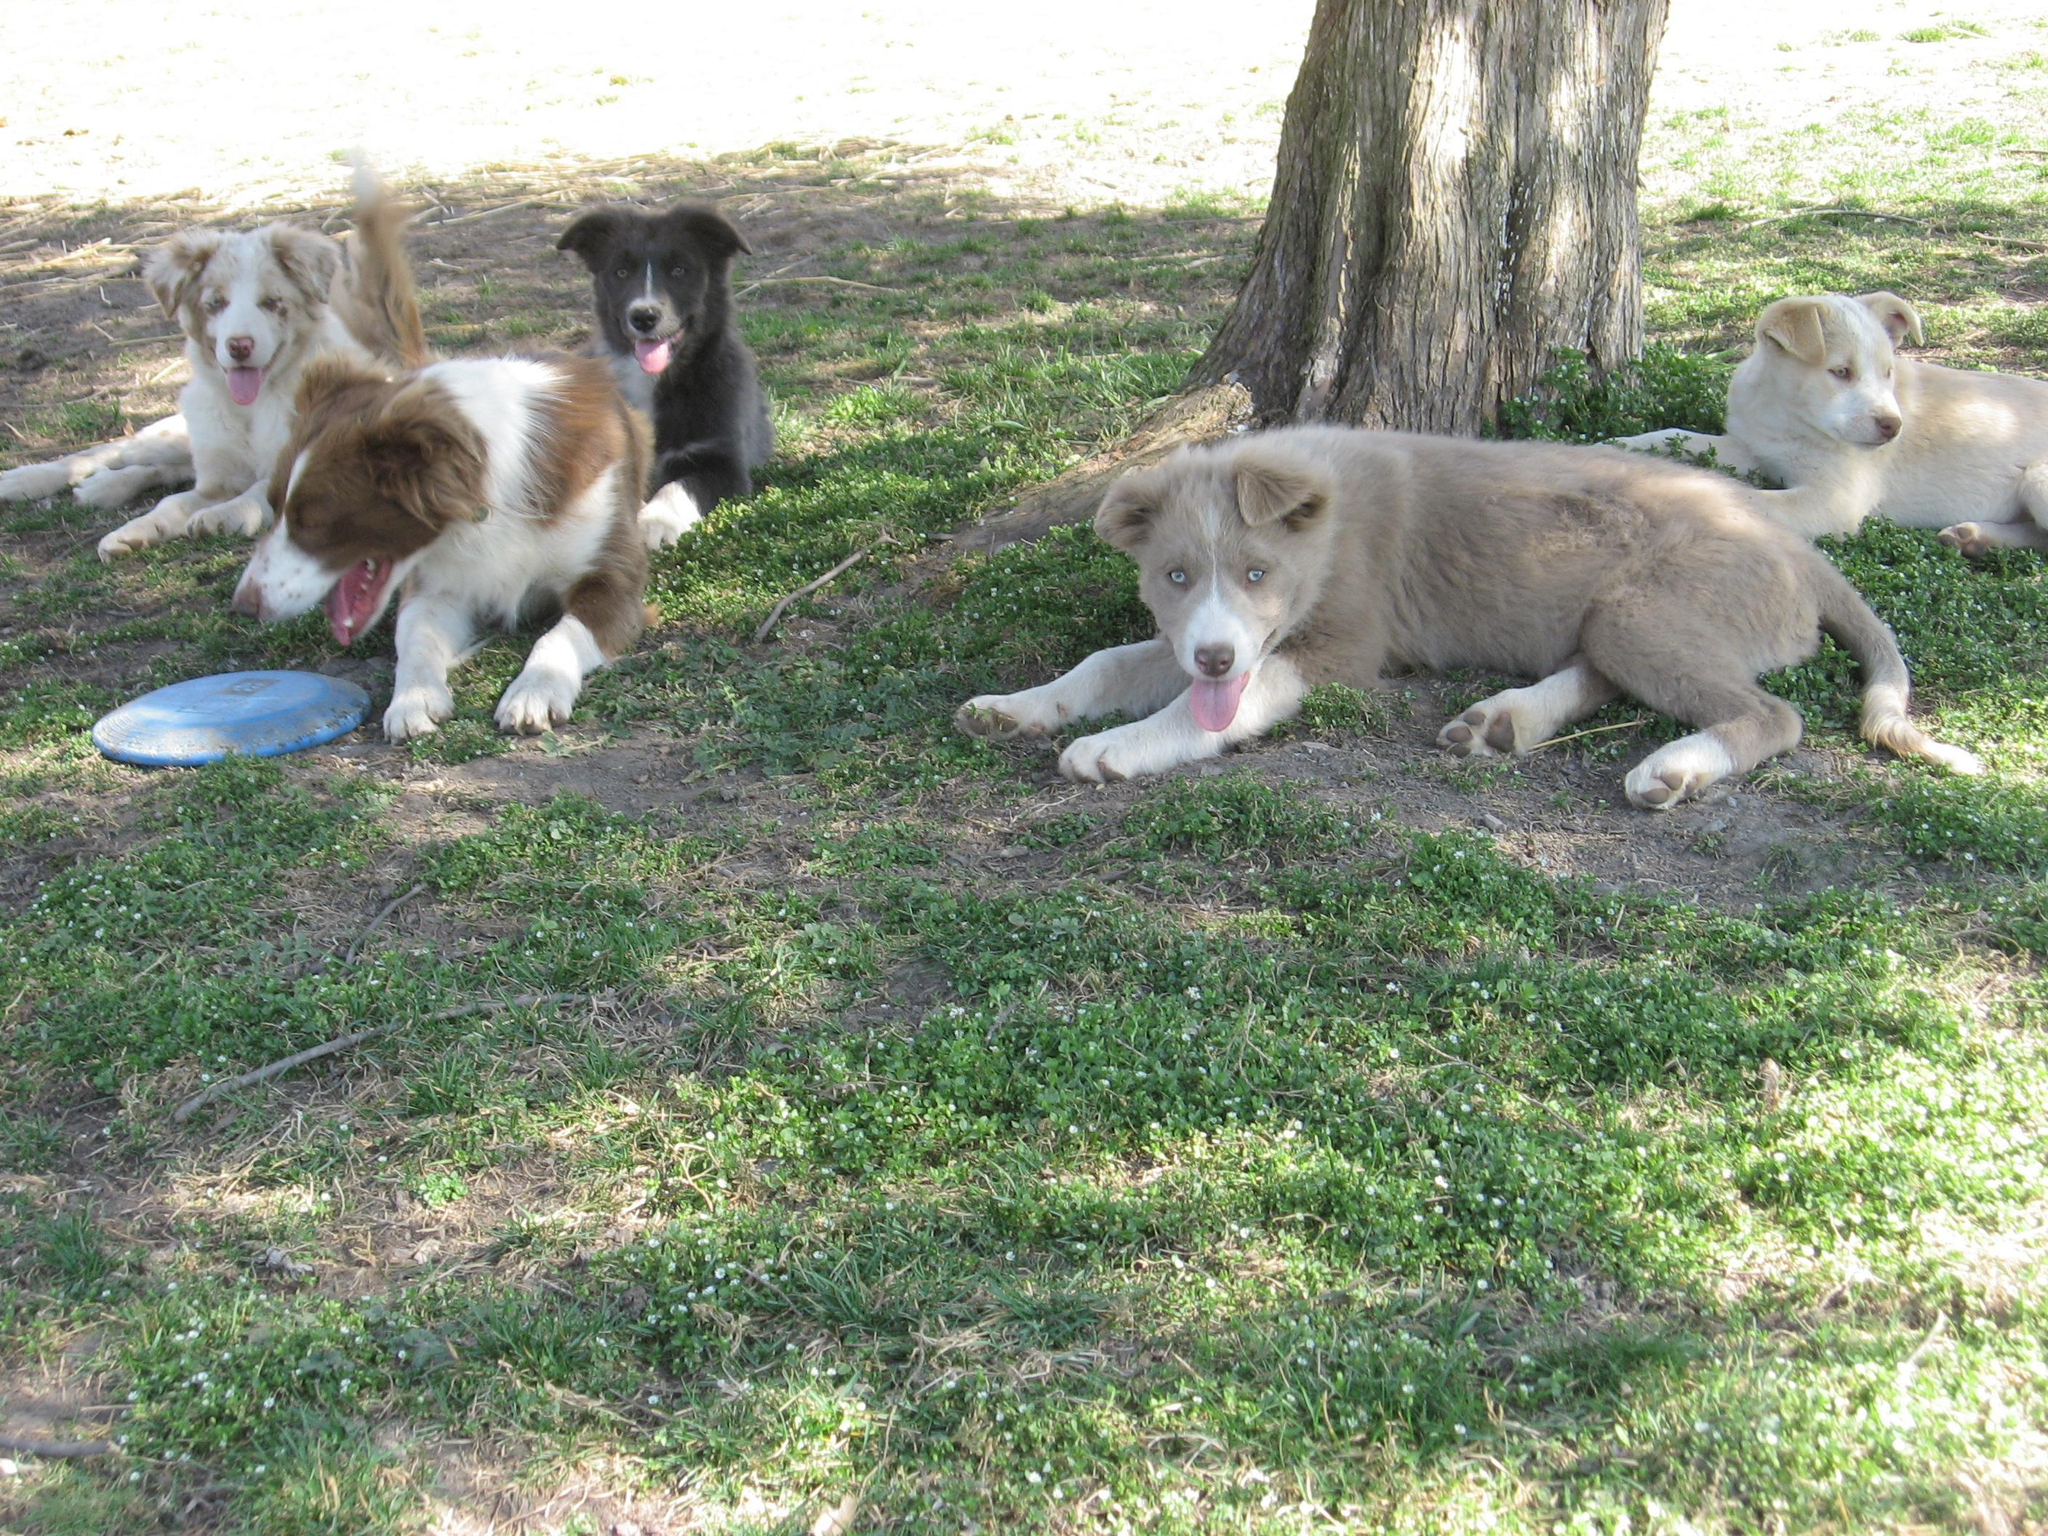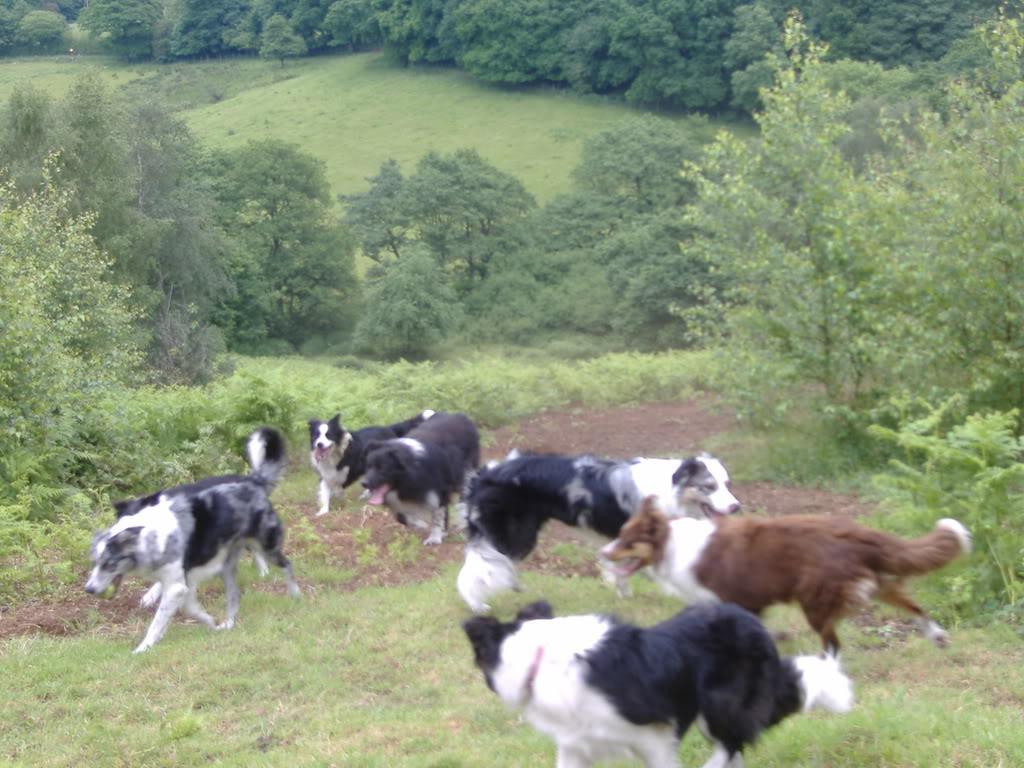The first image is the image on the left, the second image is the image on the right. Examine the images to the left and right. Is the description "A horizontal row of reclining dogs poses in front of some type of rail structure." accurate? Answer yes or no. No. The first image is the image on the left, the second image is the image on the right. For the images shown, is this caption "There are four dogs in the left image." true? Answer yes or no. Yes. 